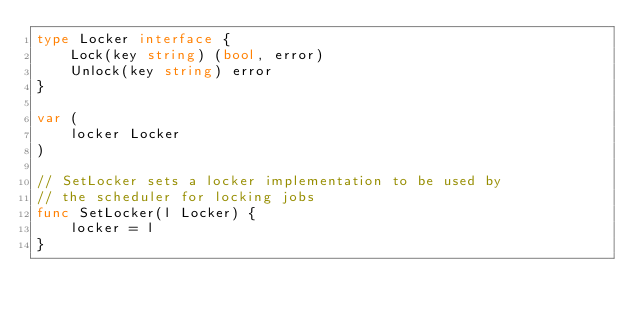Convert code to text. <code><loc_0><loc_0><loc_500><loc_500><_Go_>type Locker interface {
	Lock(key string) (bool, error)
	Unlock(key string) error
}

var (
	locker Locker
)

// SetLocker sets a locker implementation to be used by
// the scheduler for locking jobs
func SetLocker(l Locker) {
	locker = l
}
</code> 